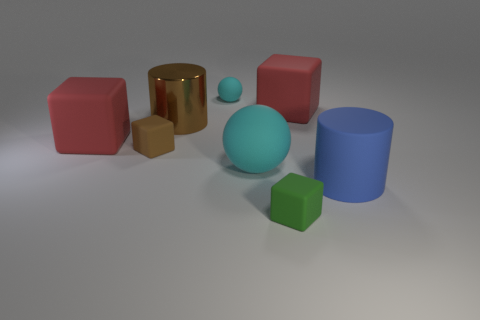Subtract 1 blocks. How many blocks are left? 3 Add 1 big brown cylinders. How many objects exist? 9 Subtract all spheres. How many objects are left? 6 Add 3 brown blocks. How many brown blocks exist? 4 Subtract 0 gray spheres. How many objects are left? 8 Subtract all tiny cyan shiny spheres. Subtract all blue matte cylinders. How many objects are left? 7 Add 1 blue rubber cylinders. How many blue rubber cylinders are left? 2 